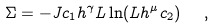<formula> <loc_0><loc_0><loc_500><loc_500>\Sigma = - J c _ { 1 } h ^ { \gamma } L \ln ( L h ^ { \mu } c _ { 2 } ) \ \ ,</formula> 